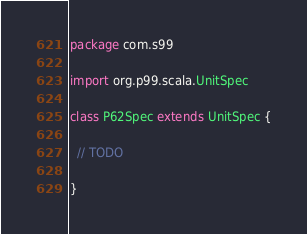Convert code to text. <code><loc_0><loc_0><loc_500><loc_500><_Scala_>package com.s99

import org.p99.scala.UnitSpec

class P62Spec extends UnitSpec {

  // TODO

}

</code> 